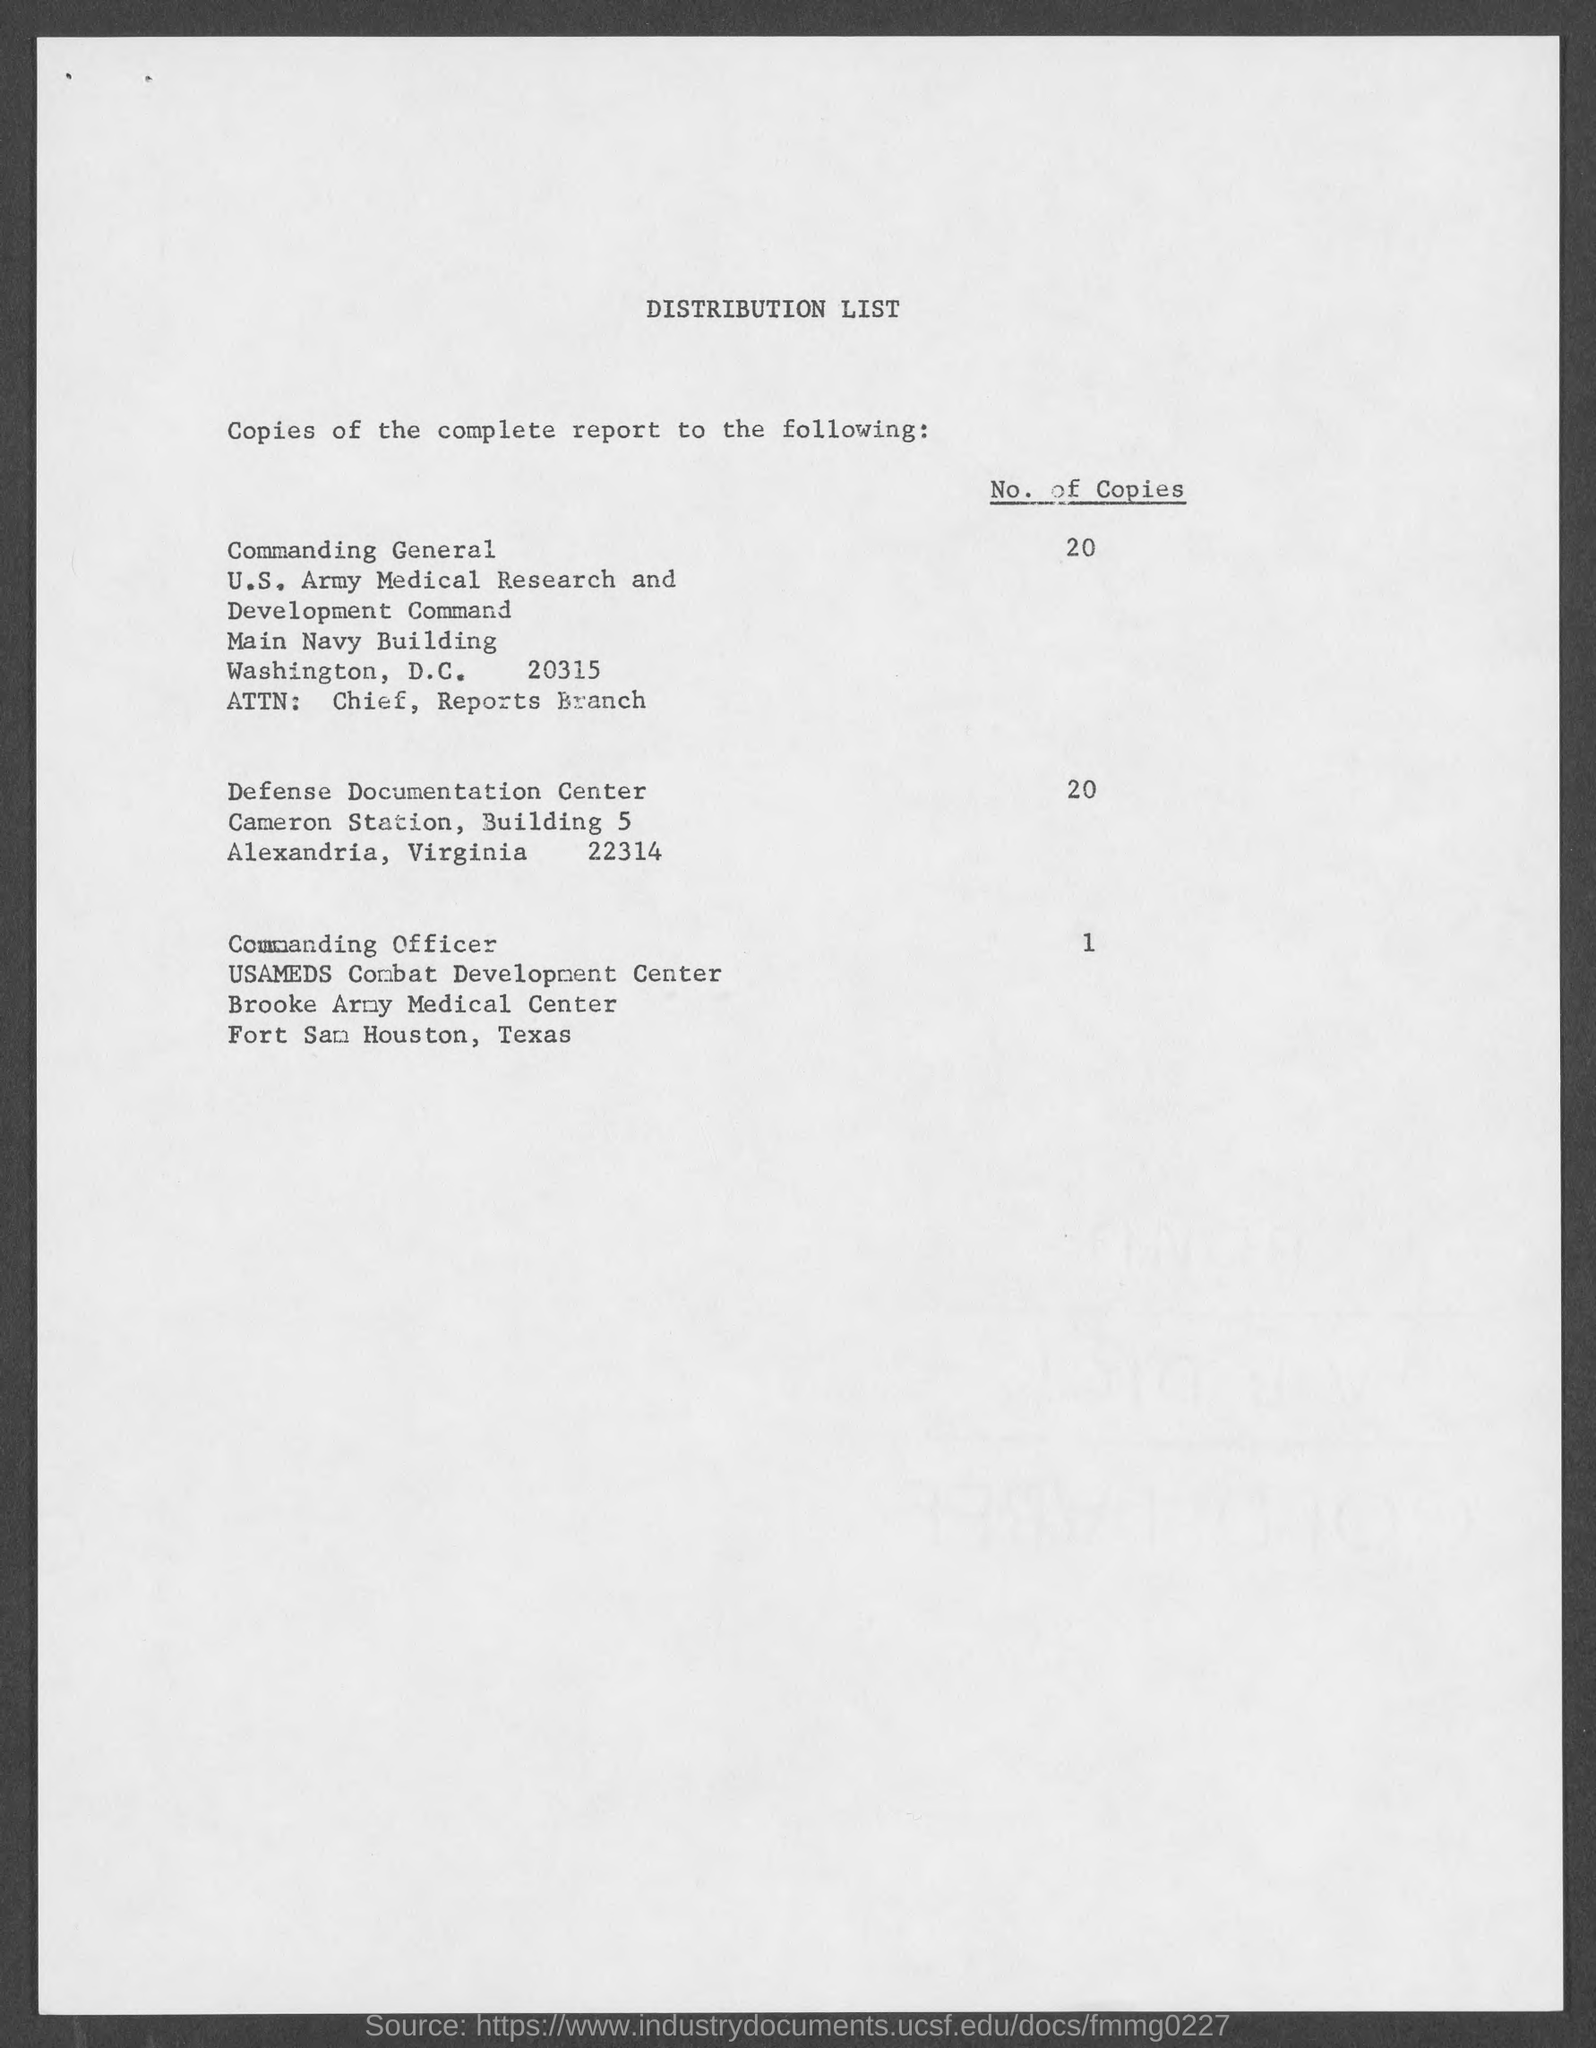What is the title of document?
Keep it short and to the point. Distribution List. What is the no. of copies for commanding general ?
Make the answer very short. 20. What is the no. of copies for defense documentation center ?
Provide a short and direct response. 20. What is the no. of copies for commanding officer?
Ensure brevity in your answer.  1. Which building is commanding general is at ?
Your answer should be compact. Main navy. What is the station where defense documentation is at ?
Ensure brevity in your answer.  Cameron. What is the city where commanding officer is at?
Offer a terse response. Fort sam houston, texas. 